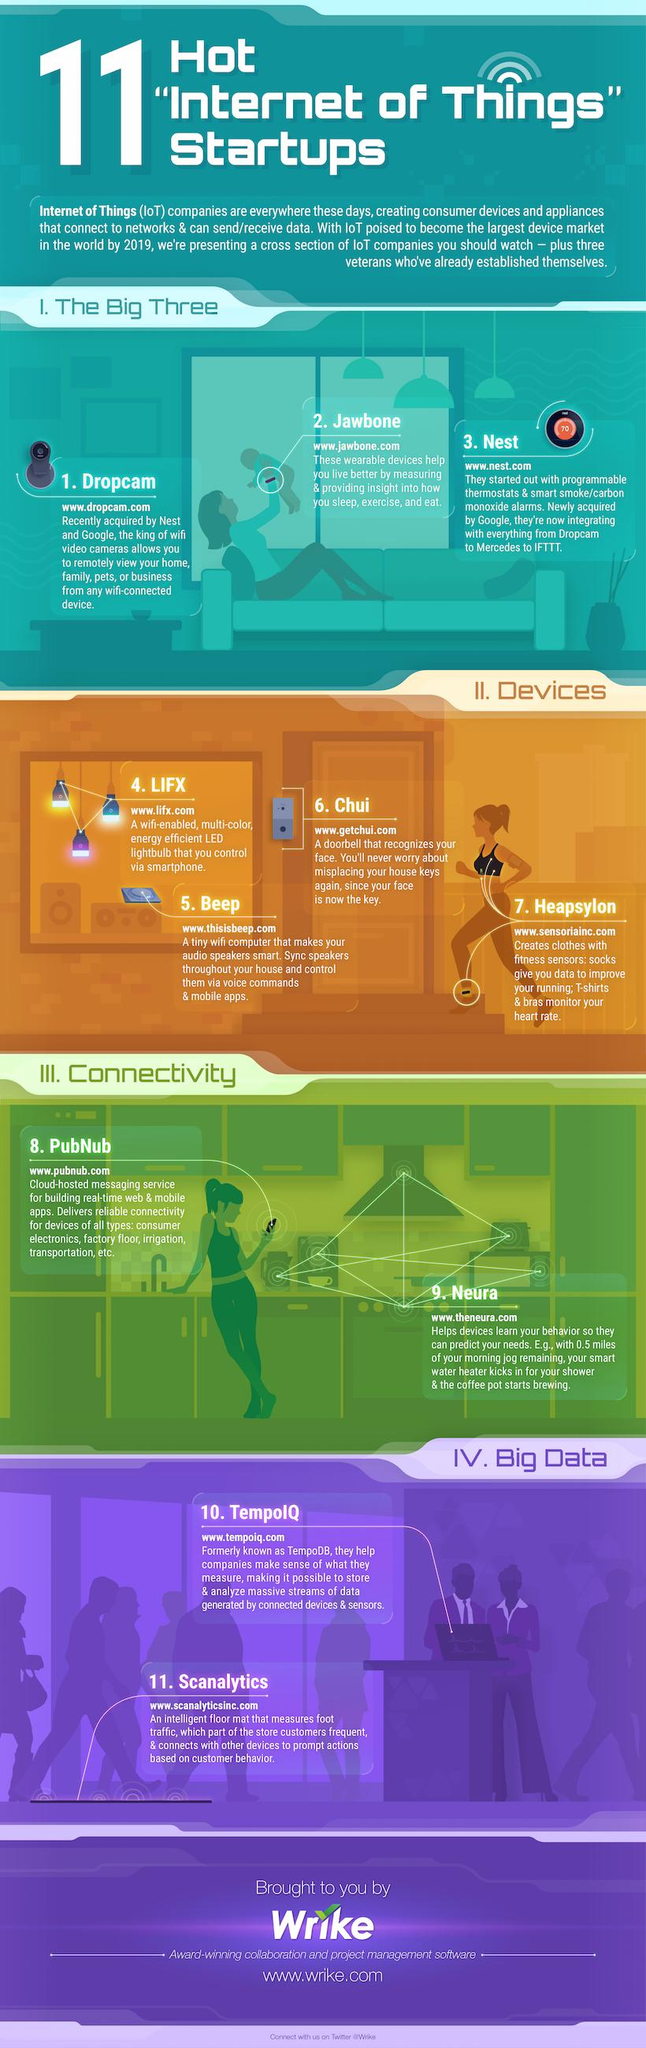Highlight a few significant elements in this photo. The third point under the heading 'devices' is 'Chui...' There are two points listed under the heading 'connectivity'. There are two points under the heading of big data. There are 4 points under the heading "devices. There are 3 points under the heading "The Big Three. 